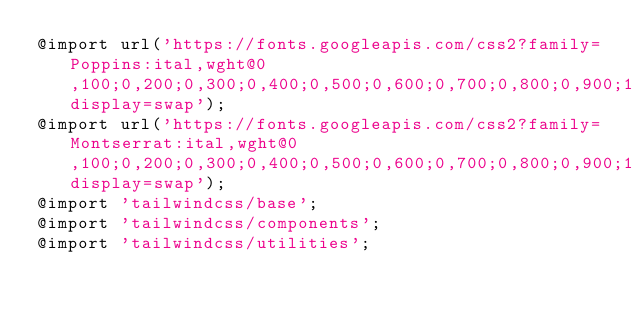<code> <loc_0><loc_0><loc_500><loc_500><_CSS_>@import url('https://fonts.googleapis.com/css2?family=Poppins:ital,wght@0,100;0,200;0,300;0,400;0,500;0,600;0,700;0,800;0,900;1,100;1,200;1,300;1,400;1,500;1,600;1,700;1,800;1,900&display=swap');
@import url('https://fonts.googleapis.com/css2?family=Montserrat:ital,wght@0,100;0,200;0,300;0,400;0,500;0,600;0,700;0,800;0,900;1,100;1,200;1,300;1,400;1,500;1,600;1,700;1,800;1,900&display=swap');
@import 'tailwindcss/base';
@import 'tailwindcss/components';
@import 'tailwindcss/utilities';</code> 